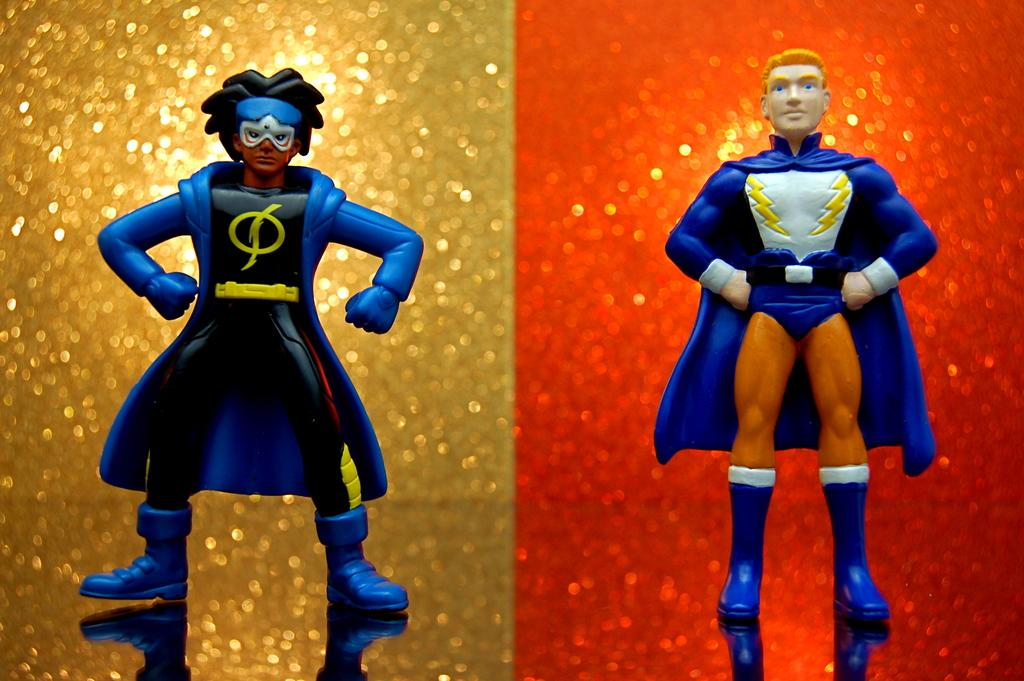How many toys are present in the image? There are two toys in the image. What can be seen in the background of the image? There are two colors in the background of the image. What are the two colors in the background? One color is gold, and the other color is red. How much zinc is present in the toys in the image? There is no information about the composition of the toys in the image, so it is impossible to determine the amount of zinc present. 